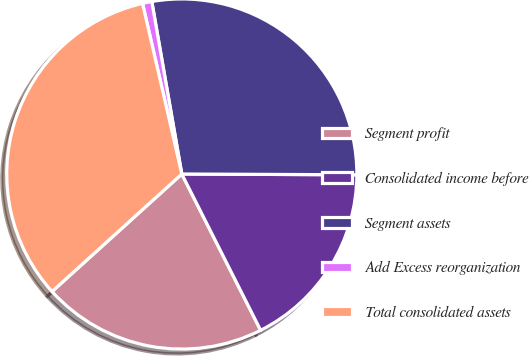<chart> <loc_0><loc_0><loc_500><loc_500><pie_chart><fcel>Segment profit<fcel>Consolidated income before<fcel>Segment assets<fcel>Add Excess reorganization<fcel>Total consolidated assets<nl><fcel>20.72%<fcel>17.49%<fcel>27.81%<fcel>0.86%<fcel>33.11%<nl></chart> 